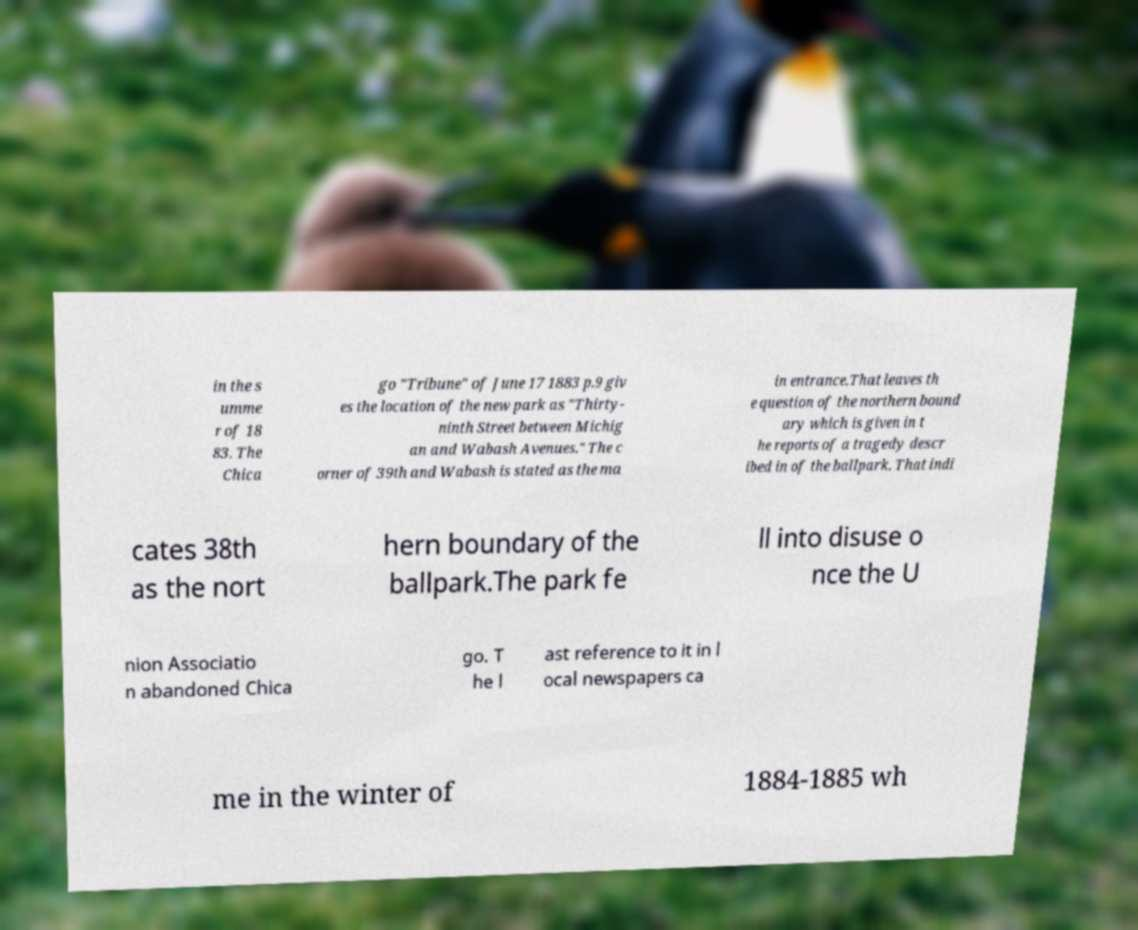Could you extract and type out the text from this image? in the s umme r of 18 83. The Chica go "Tribune" of June 17 1883 p.9 giv es the location of the new park as "Thirty- ninth Street between Michig an and Wabash Avenues." The c orner of 39th and Wabash is stated as the ma in entrance.That leaves th e question of the northern bound ary which is given in t he reports of a tragedy descr ibed in of the ballpark. That indi cates 38th as the nort hern boundary of the ballpark.The park fe ll into disuse o nce the U nion Associatio n abandoned Chica go. T he l ast reference to it in l ocal newspapers ca me in the winter of 1884-1885 wh 